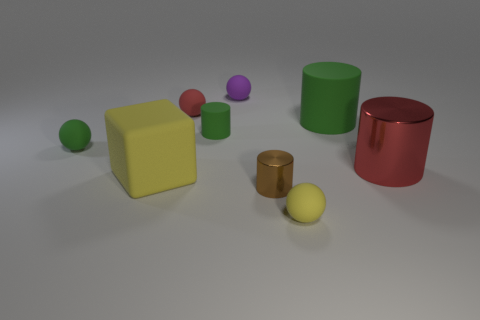Subtract all blue cubes. Subtract all red cylinders. How many cubes are left? 1 Subtract all gray cubes. How many red cylinders are left? 1 Add 1 browns. How many small greens exist? 0 Subtract all small brown cylinders. Subtract all purple spheres. How many objects are left? 7 Add 5 big red cylinders. How many big red cylinders are left? 6 Add 4 cyan cylinders. How many cyan cylinders exist? 4 Add 1 small green metal things. How many objects exist? 10 Subtract all green cylinders. How many cylinders are left? 2 Subtract all tiny metallic cylinders. How many cylinders are left? 3 Subtract 0 green blocks. How many objects are left? 9 